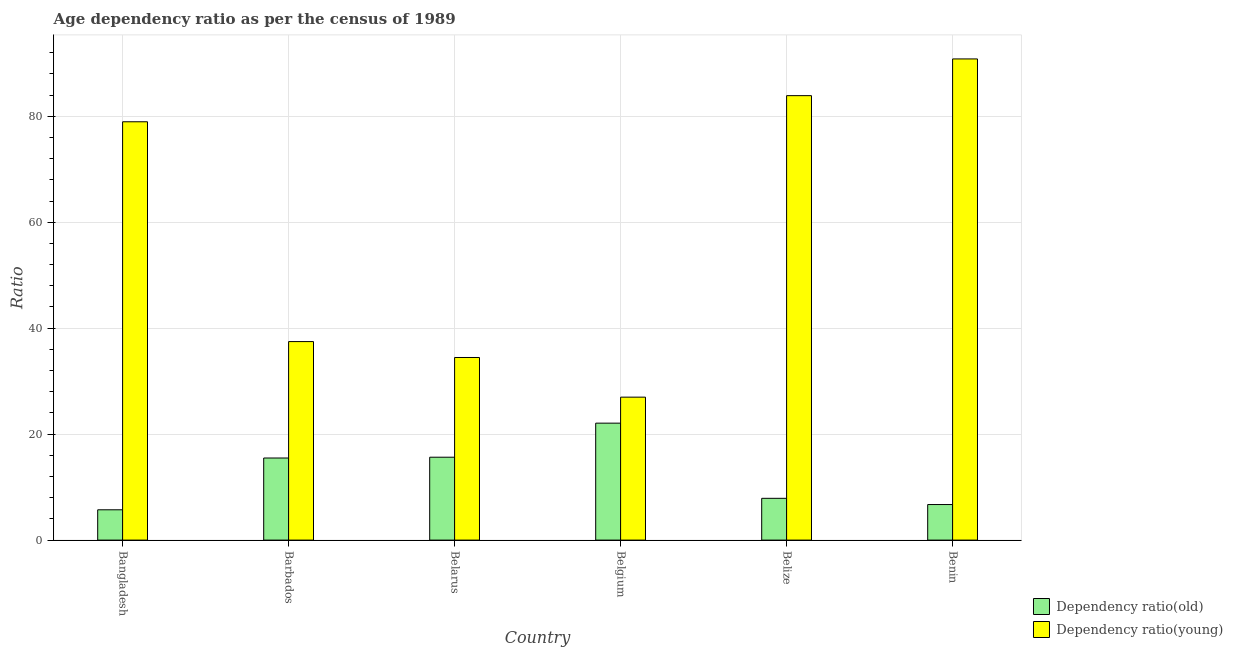How many different coloured bars are there?
Your answer should be very brief. 2. How many groups of bars are there?
Provide a succinct answer. 6. Are the number of bars per tick equal to the number of legend labels?
Your response must be concise. Yes. Are the number of bars on each tick of the X-axis equal?
Provide a succinct answer. Yes. How many bars are there on the 3rd tick from the left?
Provide a succinct answer. 2. How many bars are there on the 4th tick from the right?
Your answer should be very brief. 2. What is the label of the 2nd group of bars from the left?
Offer a terse response. Barbados. In how many cases, is the number of bars for a given country not equal to the number of legend labels?
Offer a terse response. 0. What is the age dependency ratio(old) in Belgium?
Make the answer very short. 22.07. Across all countries, what is the maximum age dependency ratio(old)?
Keep it short and to the point. 22.07. Across all countries, what is the minimum age dependency ratio(young)?
Provide a short and direct response. 26.98. In which country was the age dependency ratio(young) maximum?
Offer a terse response. Benin. What is the total age dependency ratio(young) in the graph?
Offer a very short reply. 352.6. What is the difference between the age dependency ratio(old) in Bangladesh and that in Barbados?
Provide a short and direct response. -9.77. What is the difference between the age dependency ratio(young) in Belgium and the age dependency ratio(old) in Belize?
Your answer should be very brief. 19.1. What is the average age dependency ratio(old) per country?
Ensure brevity in your answer.  12.26. What is the difference between the age dependency ratio(old) and age dependency ratio(young) in Belgium?
Give a very brief answer. -4.91. In how many countries, is the age dependency ratio(young) greater than 68 ?
Give a very brief answer. 3. What is the ratio of the age dependency ratio(old) in Belarus to that in Belgium?
Your response must be concise. 0.71. Is the age dependency ratio(old) in Belgium less than that in Benin?
Keep it short and to the point. No. Is the difference between the age dependency ratio(young) in Belarus and Belize greater than the difference between the age dependency ratio(old) in Belarus and Belize?
Your answer should be very brief. No. What is the difference between the highest and the second highest age dependency ratio(young)?
Your answer should be very brief. 6.93. What is the difference between the highest and the lowest age dependency ratio(young)?
Your answer should be compact. 63.84. In how many countries, is the age dependency ratio(old) greater than the average age dependency ratio(old) taken over all countries?
Provide a succinct answer. 3. Is the sum of the age dependency ratio(old) in Belarus and Belize greater than the maximum age dependency ratio(young) across all countries?
Provide a short and direct response. No. What does the 2nd bar from the left in Bangladesh represents?
Provide a succinct answer. Dependency ratio(young). What does the 1st bar from the right in Barbados represents?
Your answer should be very brief. Dependency ratio(young). How many bars are there?
Make the answer very short. 12. Are all the bars in the graph horizontal?
Your answer should be very brief. No. How many countries are there in the graph?
Offer a terse response. 6. What is the difference between two consecutive major ticks on the Y-axis?
Offer a very short reply. 20. Are the values on the major ticks of Y-axis written in scientific E-notation?
Your response must be concise. No. How many legend labels are there?
Provide a short and direct response. 2. How are the legend labels stacked?
Give a very brief answer. Vertical. What is the title of the graph?
Offer a terse response. Age dependency ratio as per the census of 1989. What is the label or title of the X-axis?
Offer a very short reply. Country. What is the label or title of the Y-axis?
Offer a terse response. Ratio. What is the Ratio of Dependency ratio(old) in Bangladesh?
Offer a very short reply. 5.72. What is the Ratio in Dependency ratio(young) in Bangladesh?
Ensure brevity in your answer.  78.96. What is the Ratio in Dependency ratio(old) in Barbados?
Give a very brief answer. 15.5. What is the Ratio of Dependency ratio(young) in Barbados?
Keep it short and to the point. 37.47. What is the Ratio in Dependency ratio(old) in Belarus?
Provide a succinct answer. 15.65. What is the Ratio of Dependency ratio(young) in Belarus?
Give a very brief answer. 34.47. What is the Ratio of Dependency ratio(old) in Belgium?
Offer a terse response. 22.07. What is the Ratio in Dependency ratio(young) in Belgium?
Provide a succinct answer. 26.98. What is the Ratio in Dependency ratio(old) in Belize?
Your response must be concise. 7.89. What is the Ratio in Dependency ratio(young) in Belize?
Keep it short and to the point. 83.89. What is the Ratio in Dependency ratio(old) in Benin?
Your answer should be very brief. 6.71. What is the Ratio in Dependency ratio(young) in Benin?
Provide a short and direct response. 90.82. Across all countries, what is the maximum Ratio of Dependency ratio(old)?
Offer a very short reply. 22.07. Across all countries, what is the maximum Ratio of Dependency ratio(young)?
Make the answer very short. 90.82. Across all countries, what is the minimum Ratio in Dependency ratio(old)?
Keep it short and to the point. 5.72. Across all countries, what is the minimum Ratio of Dependency ratio(young)?
Provide a short and direct response. 26.98. What is the total Ratio in Dependency ratio(old) in the graph?
Offer a terse response. 73.54. What is the total Ratio in Dependency ratio(young) in the graph?
Your response must be concise. 352.6. What is the difference between the Ratio in Dependency ratio(old) in Bangladesh and that in Barbados?
Provide a short and direct response. -9.77. What is the difference between the Ratio in Dependency ratio(young) in Bangladesh and that in Barbados?
Give a very brief answer. 41.49. What is the difference between the Ratio in Dependency ratio(old) in Bangladesh and that in Belarus?
Keep it short and to the point. -9.93. What is the difference between the Ratio of Dependency ratio(young) in Bangladesh and that in Belarus?
Your answer should be very brief. 44.49. What is the difference between the Ratio of Dependency ratio(old) in Bangladesh and that in Belgium?
Offer a very short reply. -16.35. What is the difference between the Ratio of Dependency ratio(young) in Bangladesh and that in Belgium?
Your answer should be compact. 51.98. What is the difference between the Ratio of Dependency ratio(old) in Bangladesh and that in Belize?
Provide a short and direct response. -2.16. What is the difference between the Ratio of Dependency ratio(young) in Bangladesh and that in Belize?
Give a very brief answer. -4.93. What is the difference between the Ratio of Dependency ratio(old) in Bangladesh and that in Benin?
Make the answer very short. -0.99. What is the difference between the Ratio in Dependency ratio(young) in Bangladesh and that in Benin?
Offer a terse response. -11.86. What is the difference between the Ratio in Dependency ratio(old) in Barbados and that in Belarus?
Provide a short and direct response. -0.15. What is the difference between the Ratio in Dependency ratio(young) in Barbados and that in Belarus?
Your answer should be compact. 3. What is the difference between the Ratio in Dependency ratio(old) in Barbados and that in Belgium?
Your answer should be very brief. -6.58. What is the difference between the Ratio of Dependency ratio(young) in Barbados and that in Belgium?
Your response must be concise. 10.49. What is the difference between the Ratio of Dependency ratio(old) in Barbados and that in Belize?
Provide a succinct answer. 7.61. What is the difference between the Ratio of Dependency ratio(young) in Barbados and that in Belize?
Give a very brief answer. -46.42. What is the difference between the Ratio of Dependency ratio(old) in Barbados and that in Benin?
Your answer should be very brief. 8.78. What is the difference between the Ratio of Dependency ratio(young) in Barbados and that in Benin?
Ensure brevity in your answer.  -53.35. What is the difference between the Ratio of Dependency ratio(old) in Belarus and that in Belgium?
Offer a very short reply. -6.43. What is the difference between the Ratio of Dependency ratio(young) in Belarus and that in Belgium?
Give a very brief answer. 7.49. What is the difference between the Ratio in Dependency ratio(old) in Belarus and that in Belize?
Make the answer very short. 7.76. What is the difference between the Ratio in Dependency ratio(young) in Belarus and that in Belize?
Your answer should be very brief. -49.42. What is the difference between the Ratio in Dependency ratio(old) in Belarus and that in Benin?
Provide a succinct answer. 8.93. What is the difference between the Ratio of Dependency ratio(young) in Belarus and that in Benin?
Ensure brevity in your answer.  -56.35. What is the difference between the Ratio of Dependency ratio(old) in Belgium and that in Belize?
Keep it short and to the point. 14.19. What is the difference between the Ratio of Dependency ratio(young) in Belgium and that in Belize?
Keep it short and to the point. -56.91. What is the difference between the Ratio in Dependency ratio(old) in Belgium and that in Benin?
Ensure brevity in your answer.  15.36. What is the difference between the Ratio of Dependency ratio(young) in Belgium and that in Benin?
Your answer should be very brief. -63.84. What is the difference between the Ratio of Dependency ratio(old) in Belize and that in Benin?
Give a very brief answer. 1.17. What is the difference between the Ratio in Dependency ratio(young) in Belize and that in Benin?
Make the answer very short. -6.93. What is the difference between the Ratio of Dependency ratio(old) in Bangladesh and the Ratio of Dependency ratio(young) in Barbados?
Give a very brief answer. -31.75. What is the difference between the Ratio of Dependency ratio(old) in Bangladesh and the Ratio of Dependency ratio(young) in Belarus?
Your answer should be compact. -28.75. What is the difference between the Ratio in Dependency ratio(old) in Bangladesh and the Ratio in Dependency ratio(young) in Belgium?
Your answer should be very brief. -21.26. What is the difference between the Ratio of Dependency ratio(old) in Bangladesh and the Ratio of Dependency ratio(young) in Belize?
Your response must be concise. -78.17. What is the difference between the Ratio of Dependency ratio(old) in Bangladesh and the Ratio of Dependency ratio(young) in Benin?
Ensure brevity in your answer.  -85.1. What is the difference between the Ratio of Dependency ratio(old) in Barbados and the Ratio of Dependency ratio(young) in Belarus?
Ensure brevity in your answer.  -18.97. What is the difference between the Ratio in Dependency ratio(old) in Barbados and the Ratio in Dependency ratio(young) in Belgium?
Provide a succinct answer. -11.49. What is the difference between the Ratio of Dependency ratio(old) in Barbados and the Ratio of Dependency ratio(young) in Belize?
Provide a short and direct response. -68.4. What is the difference between the Ratio in Dependency ratio(old) in Barbados and the Ratio in Dependency ratio(young) in Benin?
Keep it short and to the point. -75.33. What is the difference between the Ratio of Dependency ratio(old) in Belarus and the Ratio of Dependency ratio(young) in Belgium?
Give a very brief answer. -11.34. What is the difference between the Ratio in Dependency ratio(old) in Belarus and the Ratio in Dependency ratio(young) in Belize?
Offer a very short reply. -68.25. What is the difference between the Ratio of Dependency ratio(old) in Belarus and the Ratio of Dependency ratio(young) in Benin?
Offer a very short reply. -75.18. What is the difference between the Ratio in Dependency ratio(old) in Belgium and the Ratio in Dependency ratio(young) in Belize?
Provide a succinct answer. -61.82. What is the difference between the Ratio in Dependency ratio(old) in Belgium and the Ratio in Dependency ratio(young) in Benin?
Keep it short and to the point. -68.75. What is the difference between the Ratio of Dependency ratio(old) in Belize and the Ratio of Dependency ratio(young) in Benin?
Provide a succinct answer. -82.94. What is the average Ratio of Dependency ratio(old) per country?
Your answer should be very brief. 12.26. What is the average Ratio in Dependency ratio(young) per country?
Provide a short and direct response. 58.77. What is the difference between the Ratio of Dependency ratio(old) and Ratio of Dependency ratio(young) in Bangladesh?
Offer a terse response. -73.24. What is the difference between the Ratio in Dependency ratio(old) and Ratio in Dependency ratio(young) in Barbados?
Provide a succinct answer. -21.98. What is the difference between the Ratio in Dependency ratio(old) and Ratio in Dependency ratio(young) in Belarus?
Make the answer very short. -18.82. What is the difference between the Ratio of Dependency ratio(old) and Ratio of Dependency ratio(young) in Belgium?
Ensure brevity in your answer.  -4.91. What is the difference between the Ratio in Dependency ratio(old) and Ratio in Dependency ratio(young) in Belize?
Your answer should be compact. -76.01. What is the difference between the Ratio of Dependency ratio(old) and Ratio of Dependency ratio(young) in Benin?
Offer a very short reply. -84.11. What is the ratio of the Ratio of Dependency ratio(old) in Bangladesh to that in Barbados?
Provide a short and direct response. 0.37. What is the ratio of the Ratio of Dependency ratio(young) in Bangladesh to that in Barbados?
Provide a short and direct response. 2.11. What is the ratio of the Ratio in Dependency ratio(old) in Bangladesh to that in Belarus?
Your answer should be very brief. 0.37. What is the ratio of the Ratio in Dependency ratio(young) in Bangladesh to that in Belarus?
Offer a very short reply. 2.29. What is the ratio of the Ratio of Dependency ratio(old) in Bangladesh to that in Belgium?
Keep it short and to the point. 0.26. What is the ratio of the Ratio in Dependency ratio(young) in Bangladesh to that in Belgium?
Keep it short and to the point. 2.93. What is the ratio of the Ratio in Dependency ratio(old) in Bangladesh to that in Belize?
Make the answer very short. 0.73. What is the ratio of the Ratio in Dependency ratio(old) in Bangladesh to that in Benin?
Ensure brevity in your answer.  0.85. What is the ratio of the Ratio of Dependency ratio(young) in Bangladesh to that in Benin?
Your answer should be compact. 0.87. What is the ratio of the Ratio in Dependency ratio(old) in Barbados to that in Belarus?
Give a very brief answer. 0.99. What is the ratio of the Ratio in Dependency ratio(young) in Barbados to that in Belarus?
Your response must be concise. 1.09. What is the ratio of the Ratio of Dependency ratio(old) in Barbados to that in Belgium?
Keep it short and to the point. 0.7. What is the ratio of the Ratio of Dependency ratio(young) in Barbados to that in Belgium?
Provide a succinct answer. 1.39. What is the ratio of the Ratio in Dependency ratio(old) in Barbados to that in Belize?
Keep it short and to the point. 1.97. What is the ratio of the Ratio of Dependency ratio(young) in Barbados to that in Belize?
Your response must be concise. 0.45. What is the ratio of the Ratio in Dependency ratio(old) in Barbados to that in Benin?
Your answer should be very brief. 2.31. What is the ratio of the Ratio in Dependency ratio(young) in Barbados to that in Benin?
Offer a very short reply. 0.41. What is the ratio of the Ratio of Dependency ratio(old) in Belarus to that in Belgium?
Offer a very short reply. 0.71. What is the ratio of the Ratio of Dependency ratio(young) in Belarus to that in Belgium?
Offer a terse response. 1.28. What is the ratio of the Ratio of Dependency ratio(old) in Belarus to that in Belize?
Provide a short and direct response. 1.98. What is the ratio of the Ratio in Dependency ratio(young) in Belarus to that in Belize?
Your answer should be compact. 0.41. What is the ratio of the Ratio of Dependency ratio(old) in Belarus to that in Benin?
Provide a short and direct response. 2.33. What is the ratio of the Ratio of Dependency ratio(young) in Belarus to that in Benin?
Your answer should be compact. 0.38. What is the ratio of the Ratio in Dependency ratio(old) in Belgium to that in Belize?
Provide a succinct answer. 2.8. What is the ratio of the Ratio in Dependency ratio(young) in Belgium to that in Belize?
Provide a short and direct response. 0.32. What is the ratio of the Ratio of Dependency ratio(old) in Belgium to that in Benin?
Provide a short and direct response. 3.29. What is the ratio of the Ratio of Dependency ratio(young) in Belgium to that in Benin?
Give a very brief answer. 0.3. What is the ratio of the Ratio of Dependency ratio(old) in Belize to that in Benin?
Your response must be concise. 1.17. What is the ratio of the Ratio of Dependency ratio(young) in Belize to that in Benin?
Your answer should be very brief. 0.92. What is the difference between the highest and the second highest Ratio of Dependency ratio(old)?
Keep it short and to the point. 6.43. What is the difference between the highest and the second highest Ratio of Dependency ratio(young)?
Provide a succinct answer. 6.93. What is the difference between the highest and the lowest Ratio in Dependency ratio(old)?
Provide a short and direct response. 16.35. What is the difference between the highest and the lowest Ratio in Dependency ratio(young)?
Your response must be concise. 63.84. 